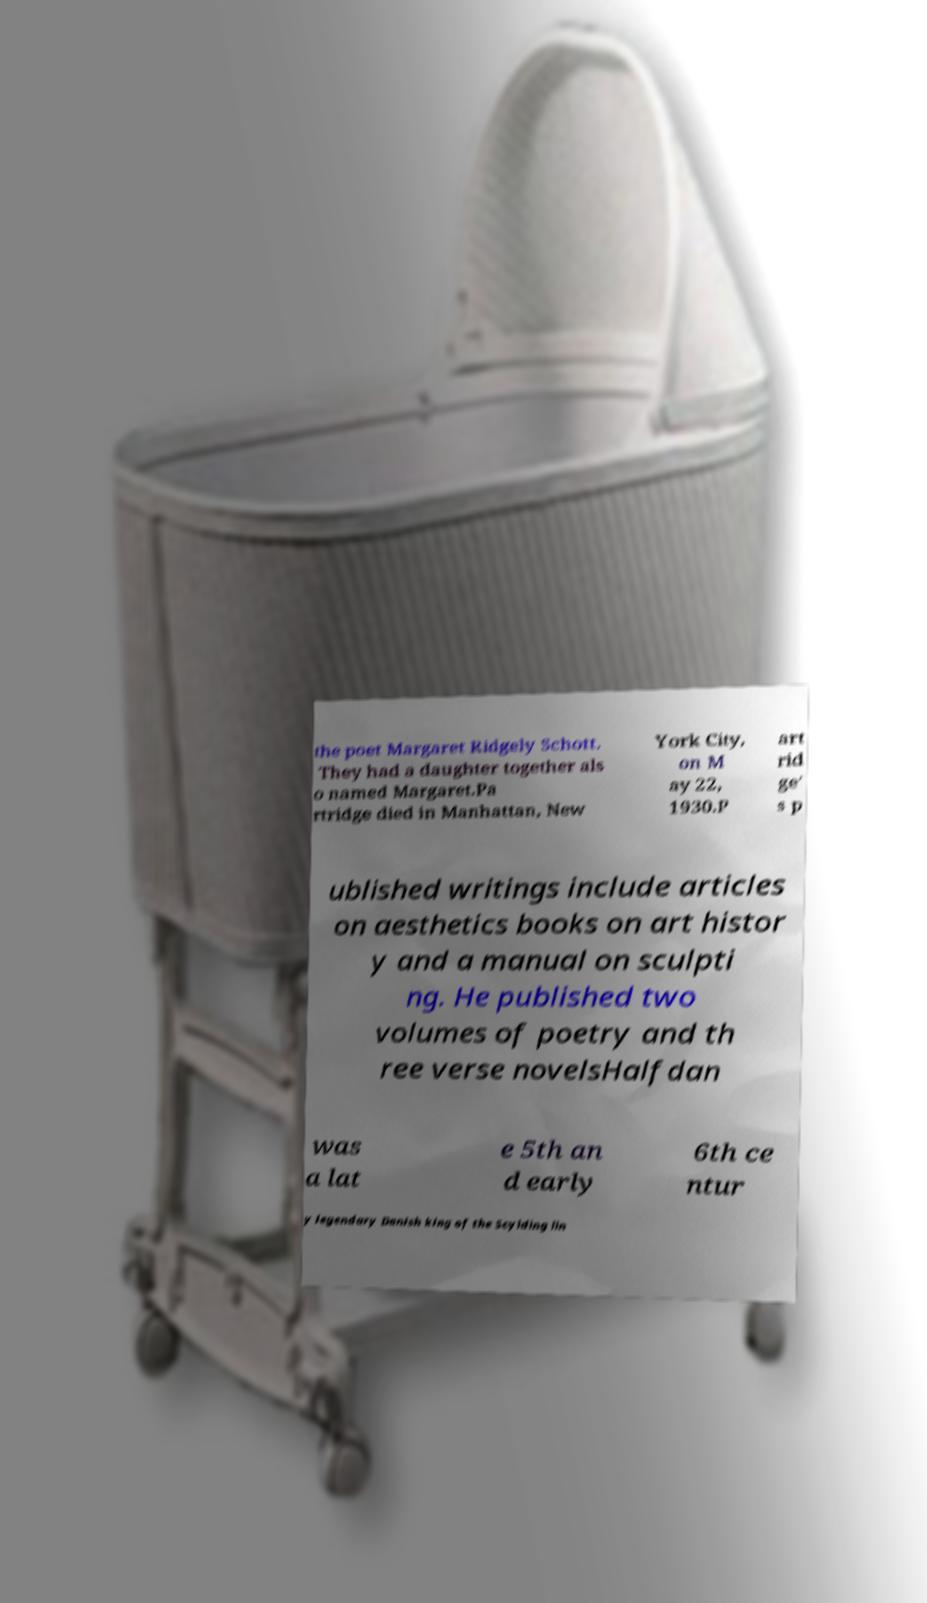Can you accurately transcribe the text from the provided image for me? the poet Margaret Ridgely Schott. They had a daughter together als o named Margaret.Pa rtridge died in Manhattan, New York City, on M ay 22, 1930.P art rid ge' s p ublished writings include articles on aesthetics books on art histor y and a manual on sculpti ng. He published two volumes of poetry and th ree verse novelsHalfdan was a lat e 5th an d early 6th ce ntur y legendary Danish king of the Scylding lin 